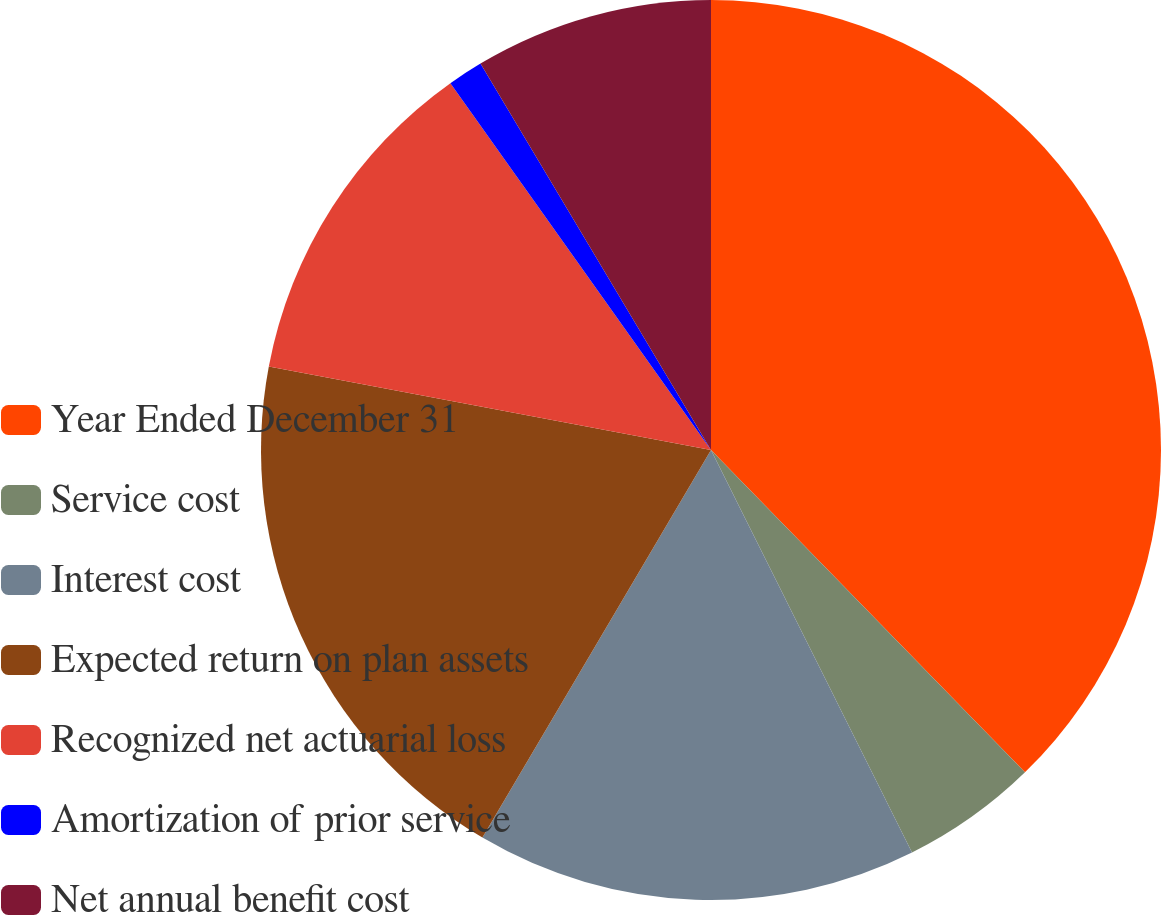<chart> <loc_0><loc_0><loc_500><loc_500><pie_chart><fcel>Year Ended December 31<fcel>Service cost<fcel>Interest cost<fcel>Expected return on plan assets<fcel>Recognized net actuarial loss<fcel>Amortization of prior service<fcel>Net annual benefit cost<nl><fcel>37.71%<fcel>4.92%<fcel>15.85%<fcel>19.49%<fcel>12.2%<fcel>1.27%<fcel>8.56%<nl></chart> 